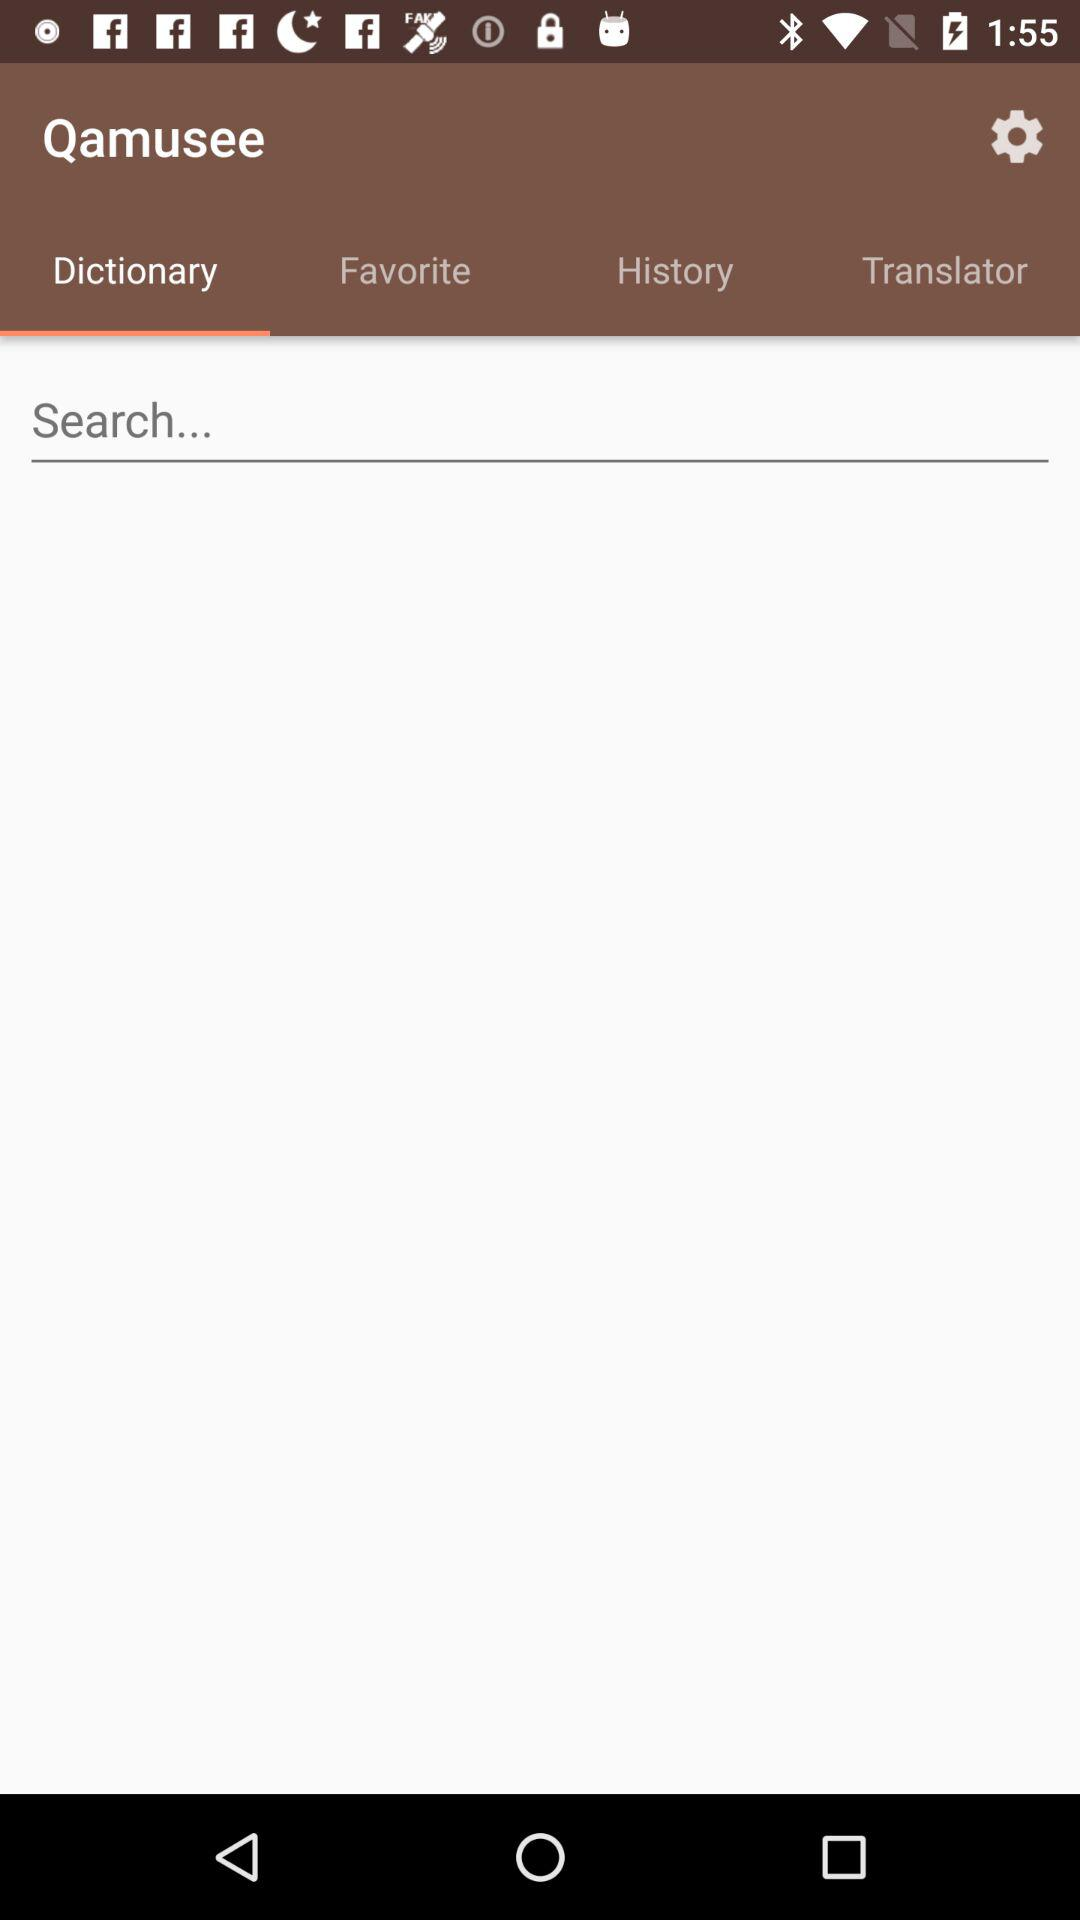How many favorites are there?
When the provided information is insufficient, respond with <no answer>. <no answer> 